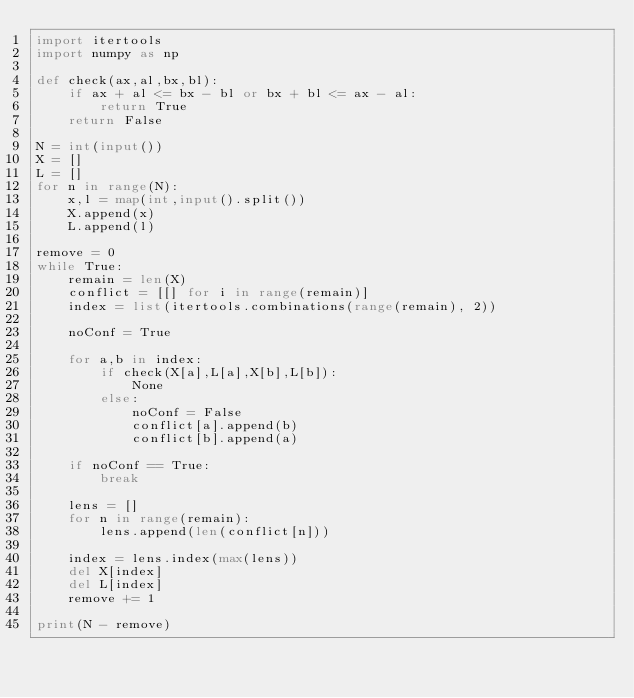<code> <loc_0><loc_0><loc_500><loc_500><_Python_>import itertools
import numpy as np

def check(ax,al,bx,bl):
    if ax + al <= bx - bl or bx + bl <= ax - al:
        return True
    return False

N = int(input())
X = []
L = []
for n in range(N):
    x,l = map(int,input().split())
    X.append(x)
    L.append(l)

remove = 0
while True:
    remain = len(X)
    conflict = [[] for i in range(remain)]
    index = list(itertools.combinations(range(remain), 2))

    noConf = True

    for a,b in index:
        if check(X[a],L[a],X[b],L[b]):
            None
        else:
            noConf = False
            conflict[a].append(b)
            conflict[b].append(a)

    if noConf == True:
        break

    lens = []
    for n in range(remain):
        lens.append(len(conflict[n]))

    index = lens.index(max(lens))
    del X[index]
    del L[index]
    remove += 1

print(N - remove)</code> 